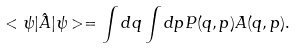Convert formula to latex. <formula><loc_0><loc_0><loc_500><loc_500>< \psi | \hat { A } | \psi > = \int d q \int d p P ( q , p ) A ( q , p ) .</formula> 